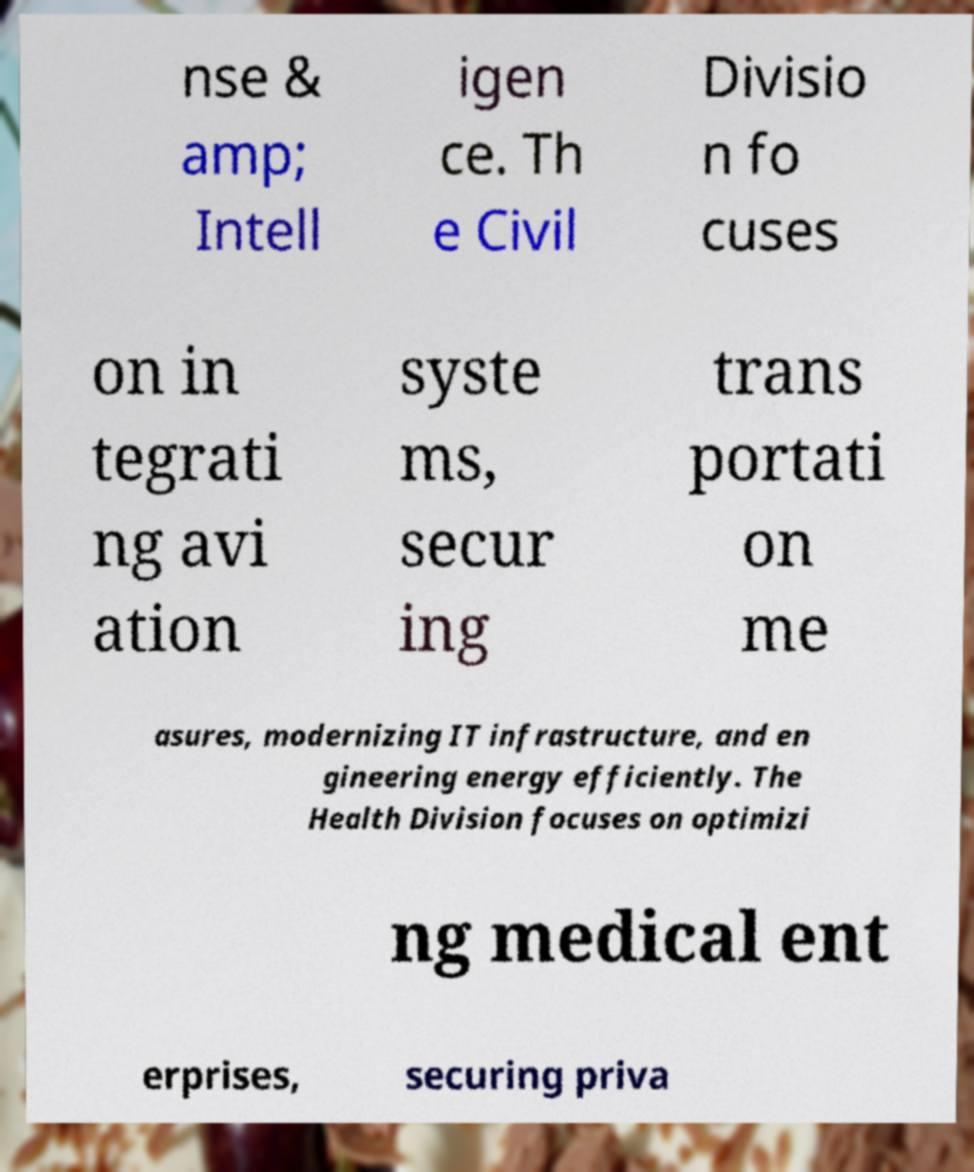Please read and relay the text visible in this image. What does it say? nse & amp; Intell igen ce. Th e Civil Divisio n fo cuses on in tegrati ng avi ation syste ms, secur ing trans portati on me asures, modernizing IT infrastructure, and en gineering energy efficiently. The Health Division focuses on optimizi ng medical ent erprises, securing priva 